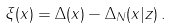<formula> <loc_0><loc_0><loc_500><loc_500>\xi ( x ) = \Delta ( x ) - \Delta _ { N } ( x | { z } ) \, .</formula> 